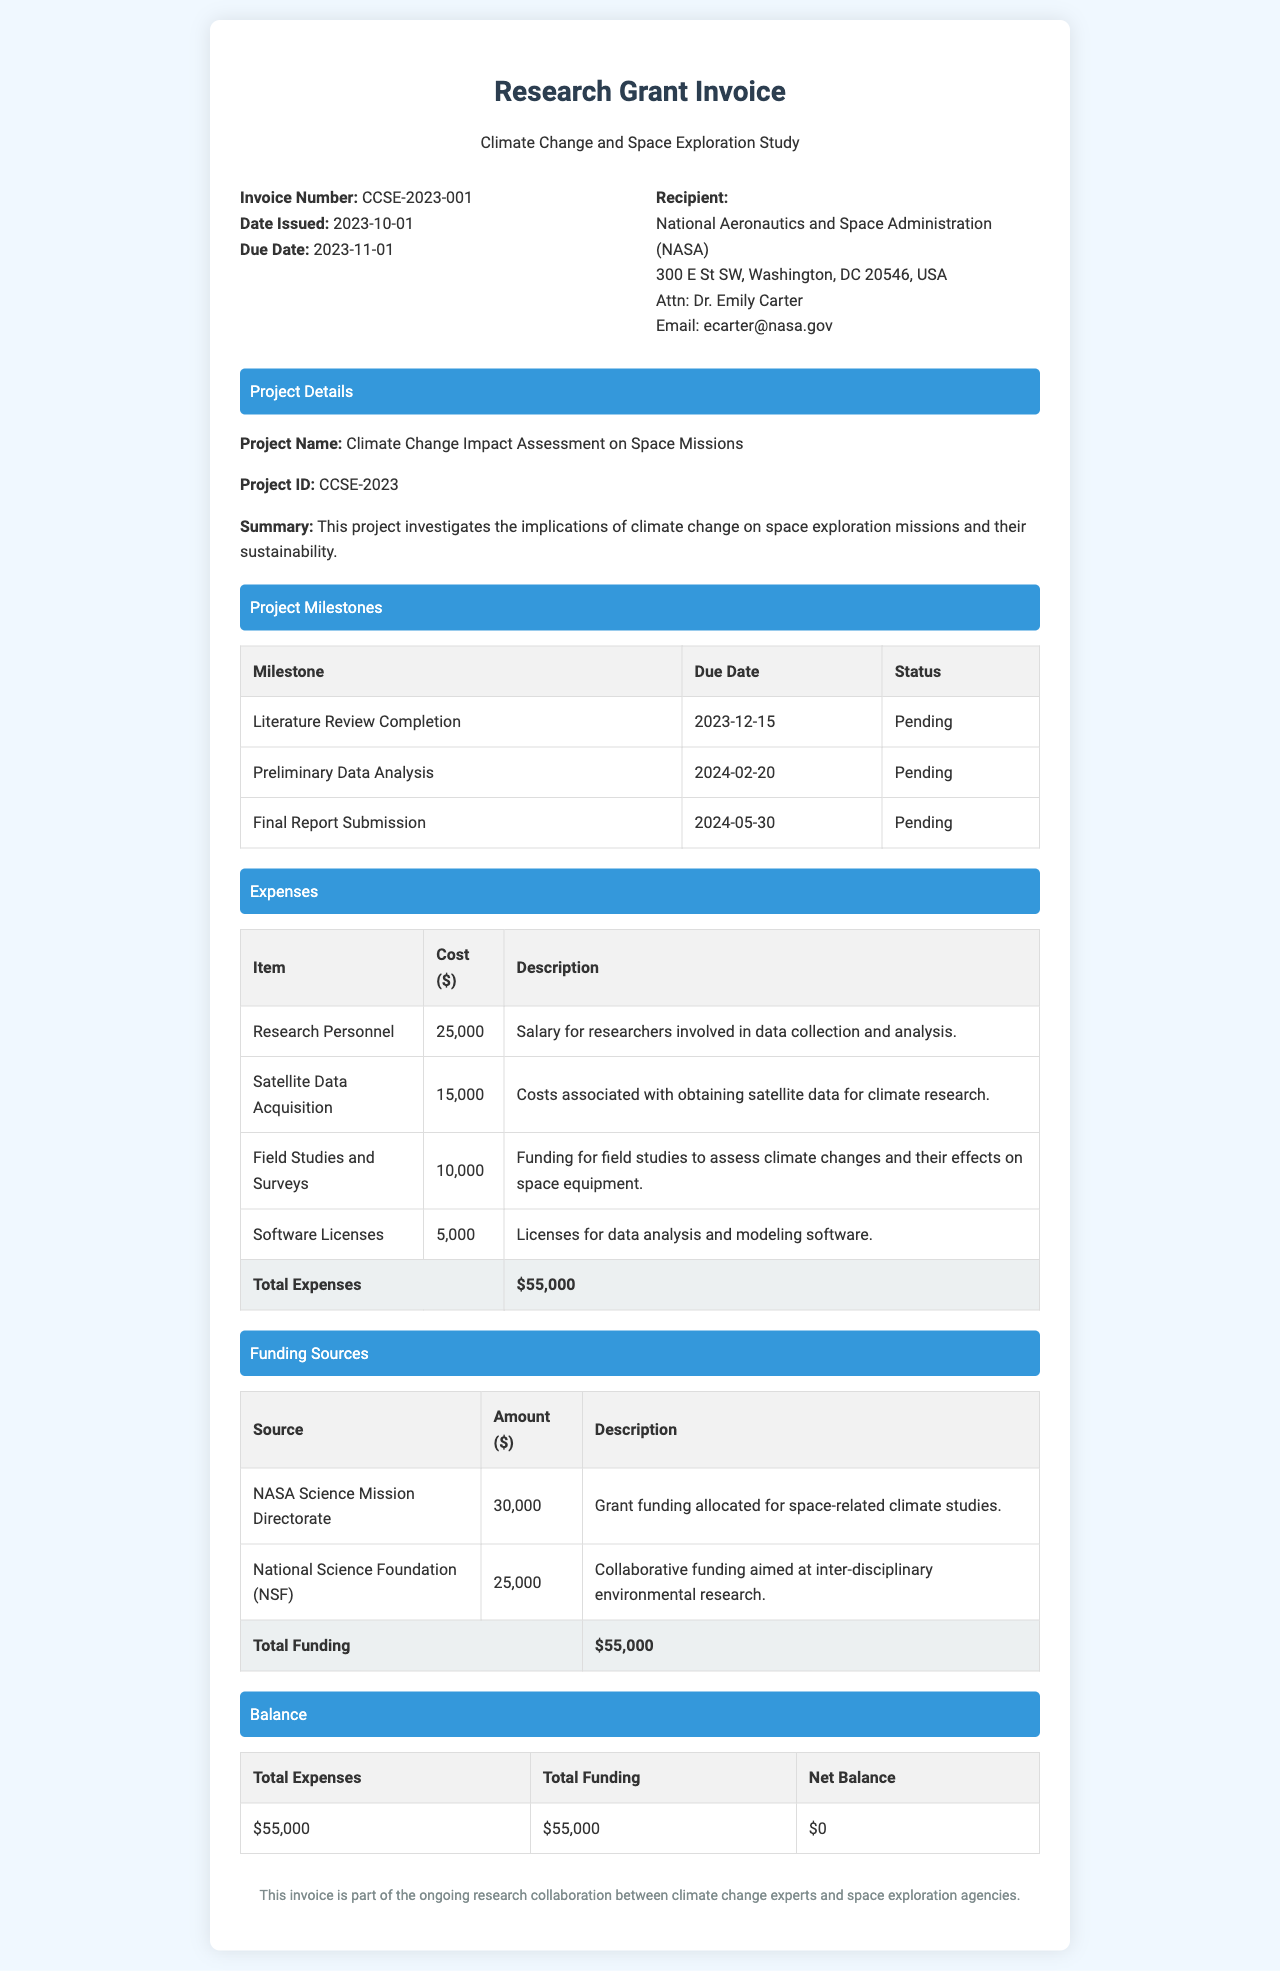What is the project name? The project name is explicitly stated in the document section titled "Project Details."
Answer: Climate Change Impact Assessment on Space Missions What is the total amount spent on research personnel? The expense table provides the specific cost for research personnel, which is found in the "Expenses" section.
Answer: $25,000 Who is the recipient of the invoice? The recipient's details are listed in the invoice details section, including the organization's name and address.
Answer: National Aeronautics and Space Administration (NASA) What is the due date of the invoice? The due date is specified in the invoice details section and indicates when payment should be made.
Answer: 2023-11-01 What is the status of the preliminary data analysis milestone? The status of each milestone is indicated in the project milestones table, showing the current progress of activities.
Answer: Pending How much total funding is allocated for this project? The total funding is calculated from the funding sources table, providing details of each source added together.
Answer: $55,000 What is the total expenses amount? The total expenses are summarized at the end of the expenses table, providing the complete cost of the project.
Answer: $55,000 What is the balance shown in the document? The balance table presents the difference between total expenses and total funding, indicating if there is any remaining amount.
Answer: $0 What is the project ID? The project ID is listed under the "Project Details" section, providing a unique identifier for the research project.
Answer: CCSE-2023 